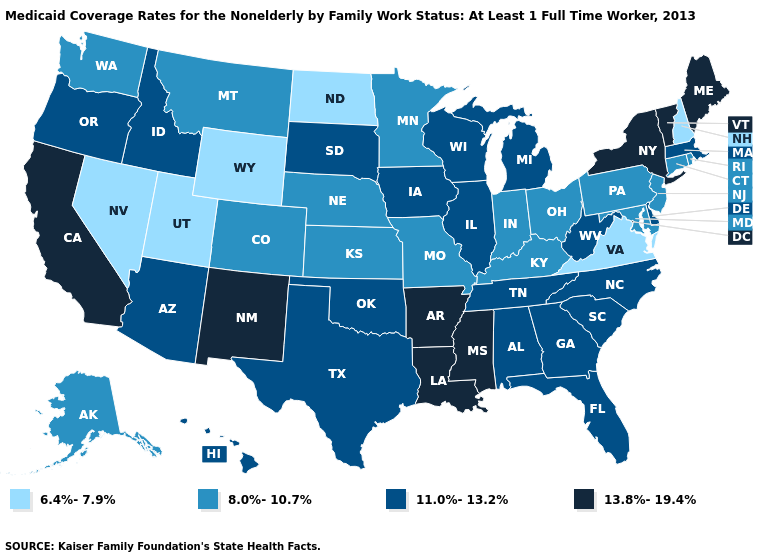Which states have the lowest value in the Northeast?
Give a very brief answer. New Hampshire. What is the lowest value in the Northeast?
Give a very brief answer. 6.4%-7.9%. What is the value of Iowa?
Answer briefly. 11.0%-13.2%. Does Pennsylvania have a lower value than California?
Give a very brief answer. Yes. What is the value of Ohio?
Short answer required. 8.0%-10.7%. Name the states that have a value in the range 8.0%-10.7%?
Concise answer only. Alaska, Colorado, Connecticut, Indiana, Kansas, Kentucky, Maryland, Minnesota, Missouri, Montana, Nebraska, New Jersey, Ohio, Pennsylvania, Rhode Island, Washington. What is the value of South Carolina?
Answer briefly. 11.0%-13.2%. What is the value of Missouri?
Short answer required. 8.0%-10.7%. Which states have the lowest value in the MidWest?
Concise answer only. North Dakota. Name the states that have a value in the range 13.8%-19.4%?
Concise answer only. Arkansas, California, Louisiana, Maine, Mississippi, New Mexico, New York, Vermont. What is the lowest value in the USA?
Keep it brief. 6.4%-7.9%. What is the value of Louisiana?
Answer briefly. 13.8%-19.4%. Name the states that have a value in the range 13.8%-19.4%?
Keep it brief. Arkansas, California, Louisiana, Maine, Mississippi, New Mexico, New York, Vermont. Name the states that have a value in the range 8.0%-10.7%?
Answer briefly. Alaska, Colorado, Connecticut, Indiana, Kansas, Kentucky, Maryland, Minnesota, Missouri, Montana, Nebraska, New Jersey, Ohio, Pennsylvania, Rhode Island, Washington. Which states have the highest value in the USA?
Short answer required. Arkansas, California, Louisiana, Maine, Mississippi, New Mexico, New York, Vermont. 